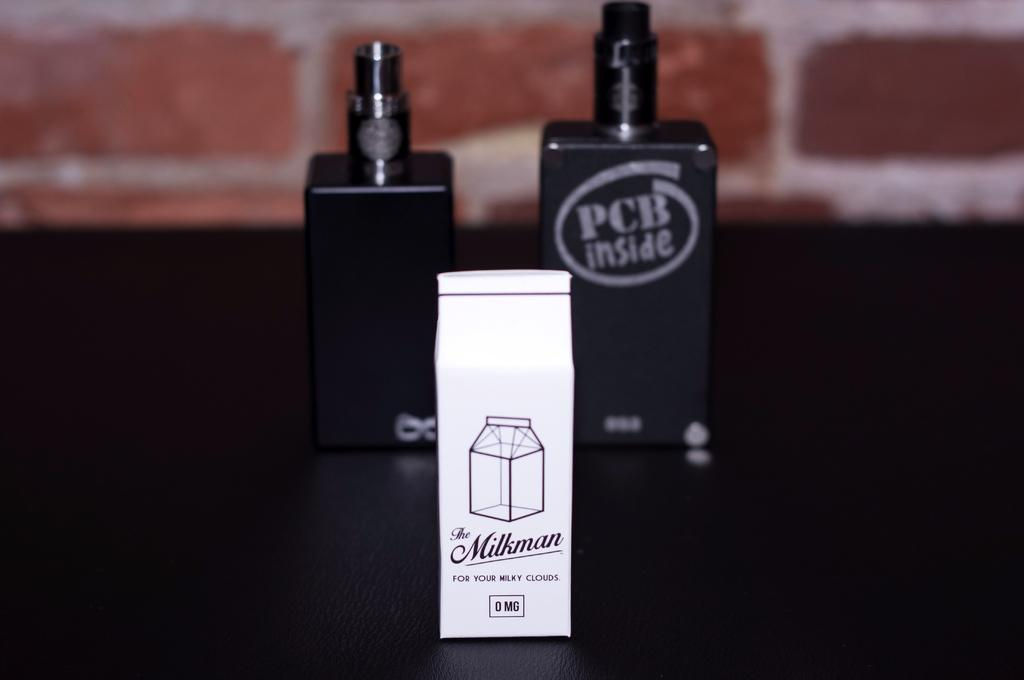Provide a one-sentence caption for the provided image. A small white carton named "The Milkman" in front of a vape. 